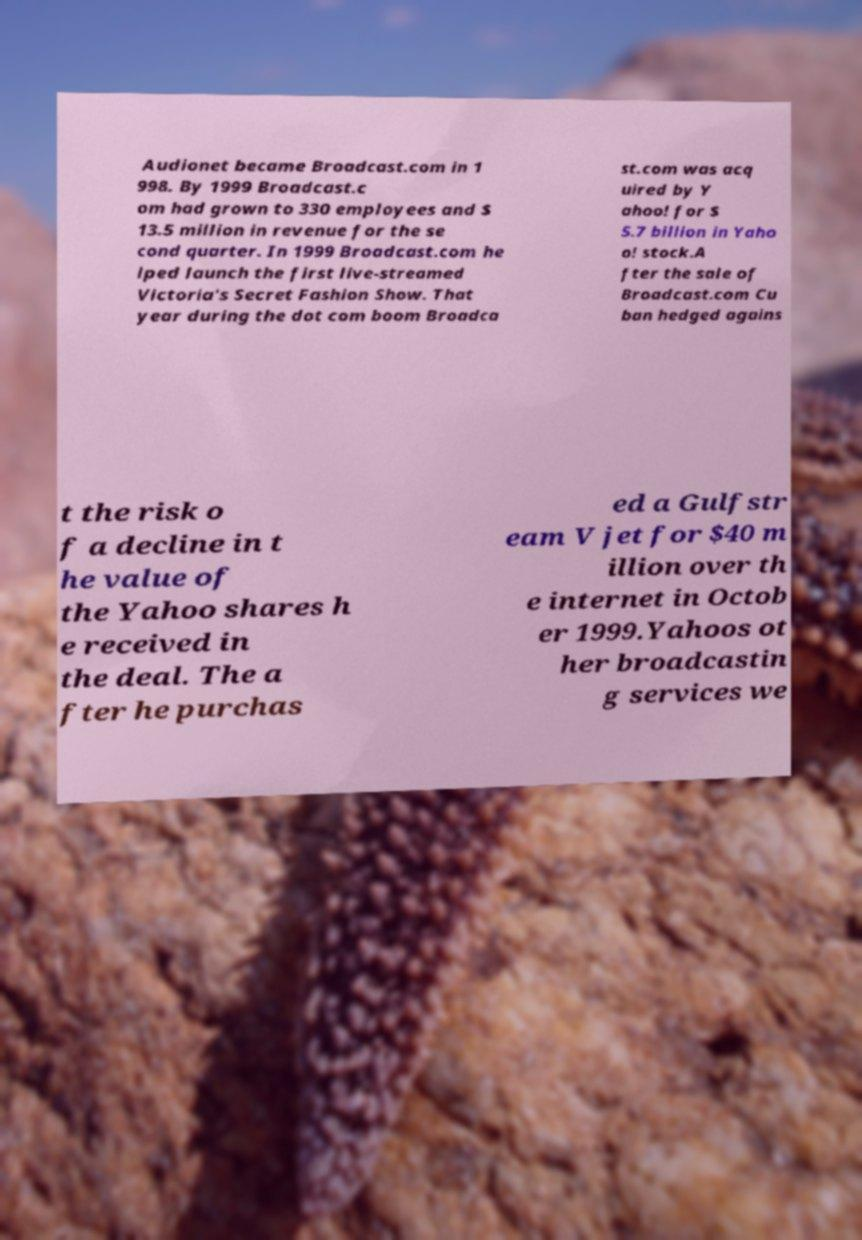Could you assist in decoding the text presented in this image and type it out clearly? Audionet became Broadcast.com in 1 998. By 1999 Broadcast.c om had grown to 330 employees and $ 13.5 million in revenue for the se cond quarter. In 1999 Broadcast.com he lped launch the first live-streamed Victoria's Secret Fashion Show. That year during the dot com boom Broadca st.com was acq uired by Y ahoo! for $ 5.7 billion in Yaho o! stock.A fter the sale of Broadcast.com Cu ban hedged agains t the risk o f a decline in t he value of the Yahoo shares h e received in the deal. The a fter he purchas ed a Gulfstr eam V jet for $40 m illion over th e internet in Octob er 1999.Yahoos ot her broadcastin g services we 